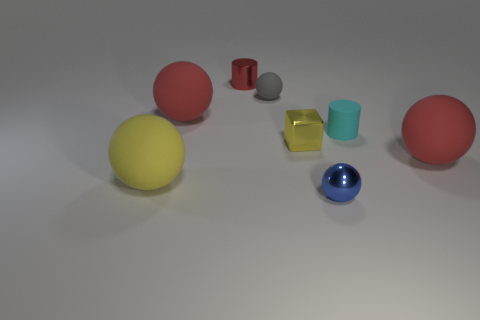Subtract all blue spheres. How many spheres are left? 4 Subtract all small blue spheres. How many spheres are left? 4 Subtract all brown balls. Subtract all green blocks. How many balls are left? 5 Add 1 cyan things. How many objects exist? 9 Subtract all cylinders. How many objects are left? 6 Subtract all large yellow metallic objects. Subtract all big rubber things. How many objects are left? 5 Add 1 yellow balls. How many yellow balls are left? 2 Add 5 red rubber objects. How many red rubber objects exist? 7 Subtract 0 brown cylinders. How many objects are left? 8 